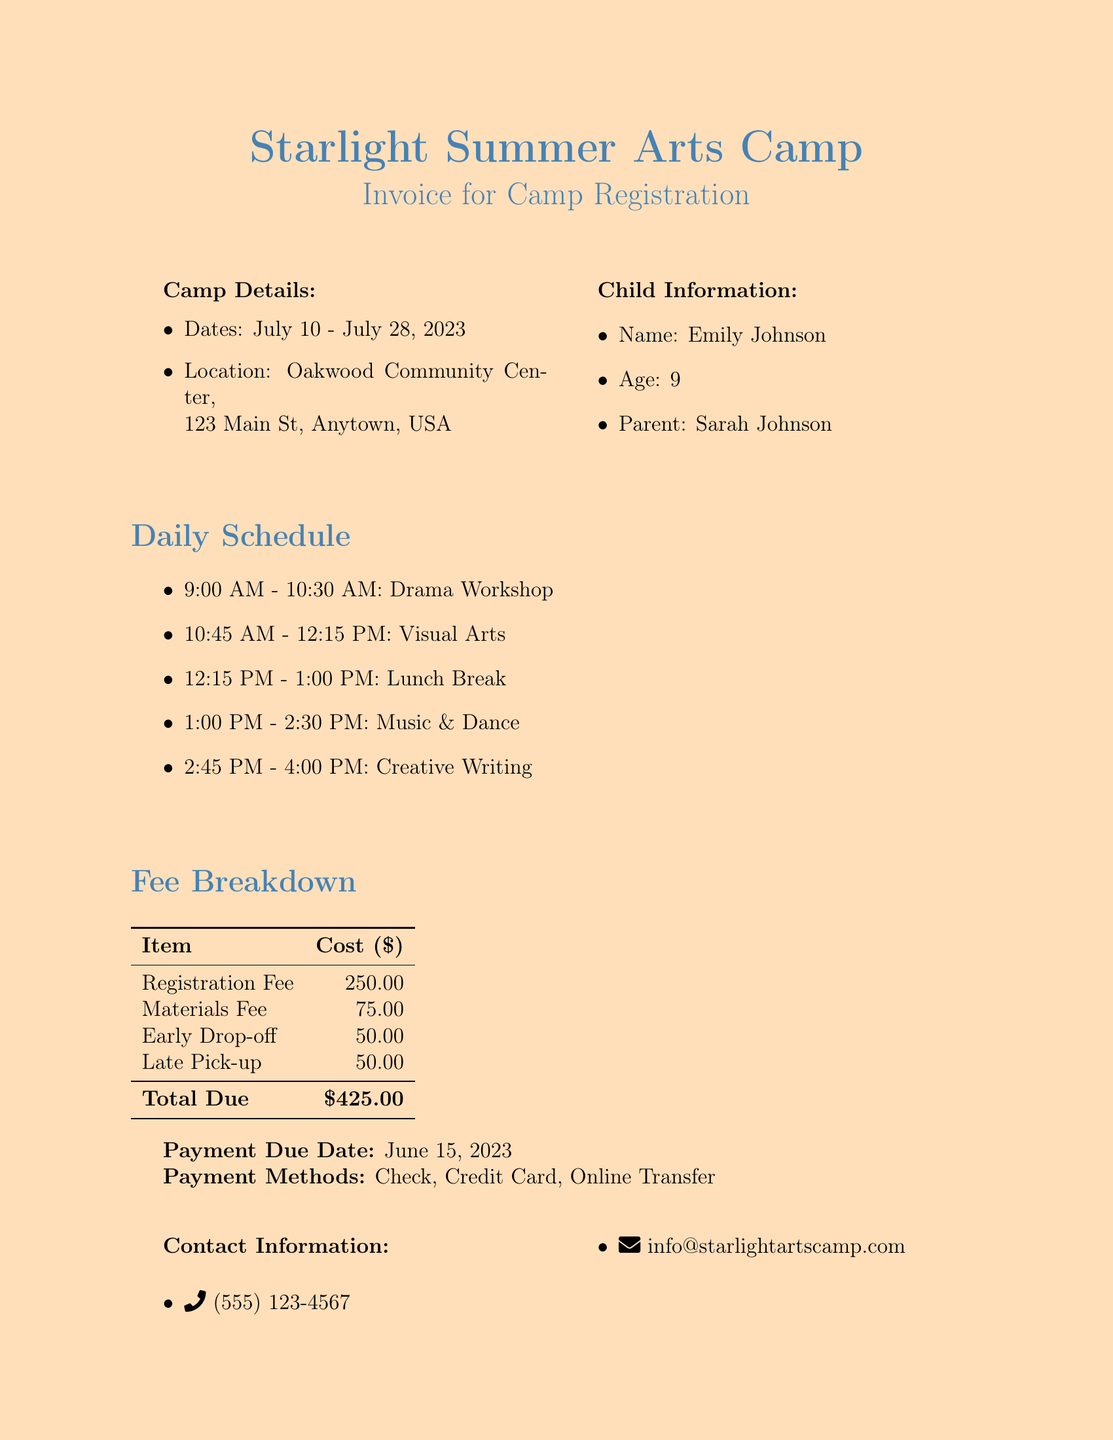What are the camp dates? The camp dates are explicitly listed in the document as July 10 - July 28, 2023.
Answer: July 10 - July 28, 2023 What is the location of the camp? The location is provided in the document as Oakwood Community Center, 123 Main St, Anytown, USA.
Answer: Oakwood Community Center, 123 Main St, Anytown, USA Who is the parent of the child registered? The document states that the child's parent is Sarah Johnson.
Answer: Sarah Johnson What is the total amount due? The total amount due is clearly stated at the end of the fee breakdown as $425.00.
Answer: $425.00 What is the materials fee? The materials fee is listed in the fee breakdown section, indicating the cost associated with materials for the camp.
Answer: $75.00 How much is the early drop-off fee? The document specifies the cost for early drop-off as part of the fee breakdown.
Answer: $50.00 When is the payment due date? The payment due date is detailed in the document and gives a specific date.
Answer: June 15, 2023 What payment methods are accepted? The document outlines that different payment methods are available for parents, ensuring flexible options.
Answer: Check, Credit Card, Online Transfer Is there a discount available for siblings? The document mentions whether siblings can receive any discounts, hinting at additional benefits.
Answer: 10% sibling discount available 